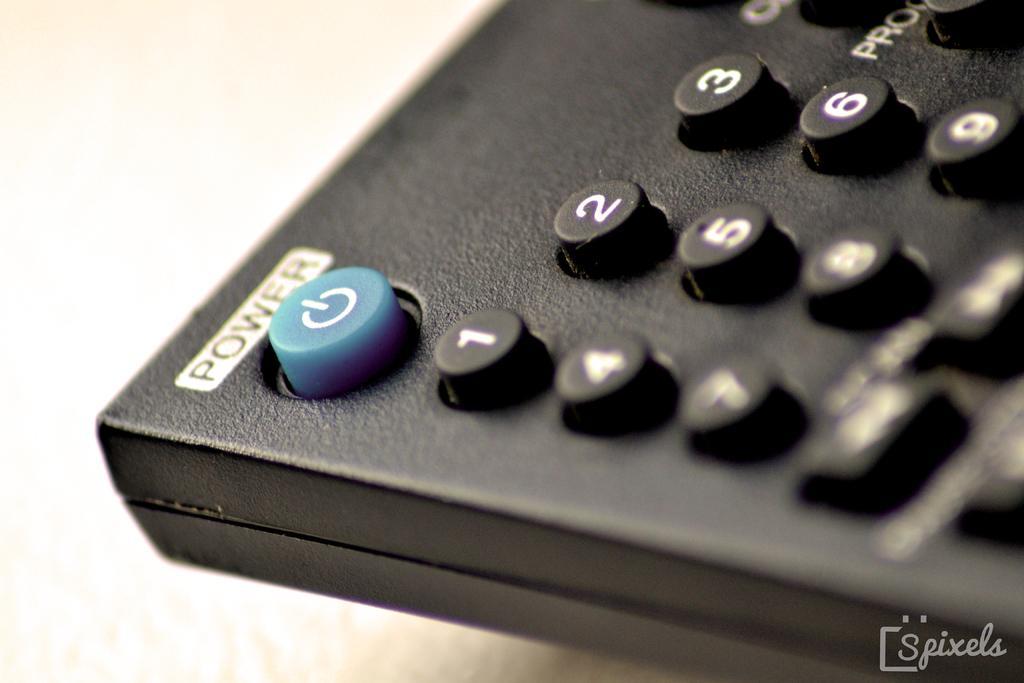Describe this image in one or two sentences. Here we can see remote with power button and number buttons. Bottom right of the image we can see watermark. 